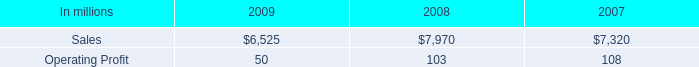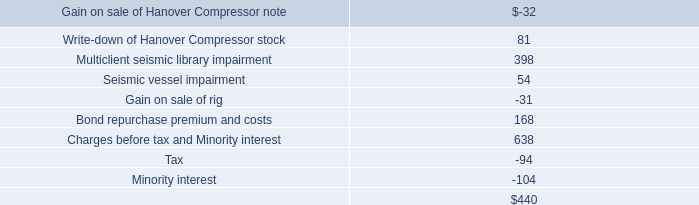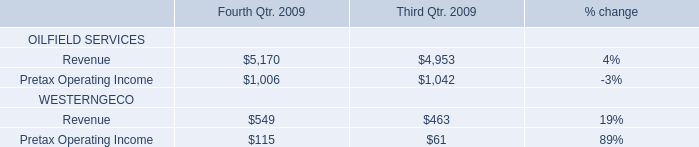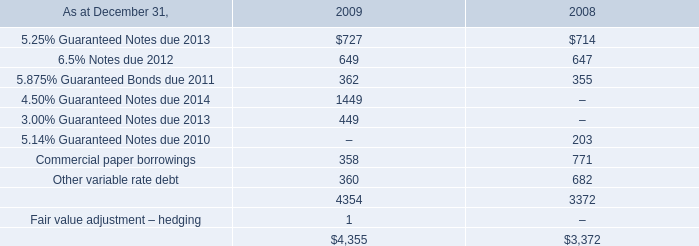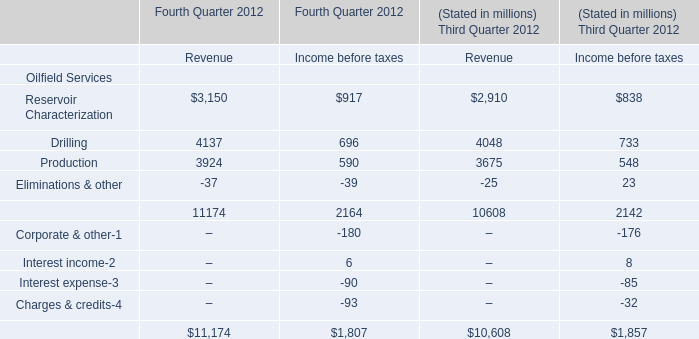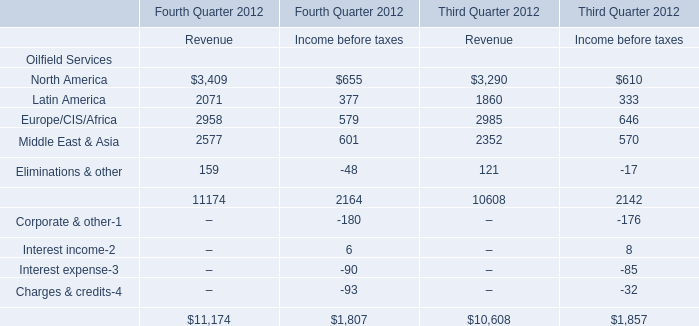What was the total amount of Revenue excluding those Revenue greater than 4000 for Fourth Quarter 2012? (in million) 
Computations: ((3150 + 3924) - 37)
Answer: 7037.0. 